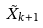<formula> <loc_0><loc_0><loc_500><loc_500>\tilde { X } _ { k + 1 }</formula> 